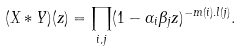<formula> <loc_0><loc_0><loc_500><loc_500>( X * Y ) ( z ) = \prod _ { i , j } ( 1 - \alpha _ { i } \beta _ { j } z ) ^ { - m ( i ) . l ( j ) } .</formula> 